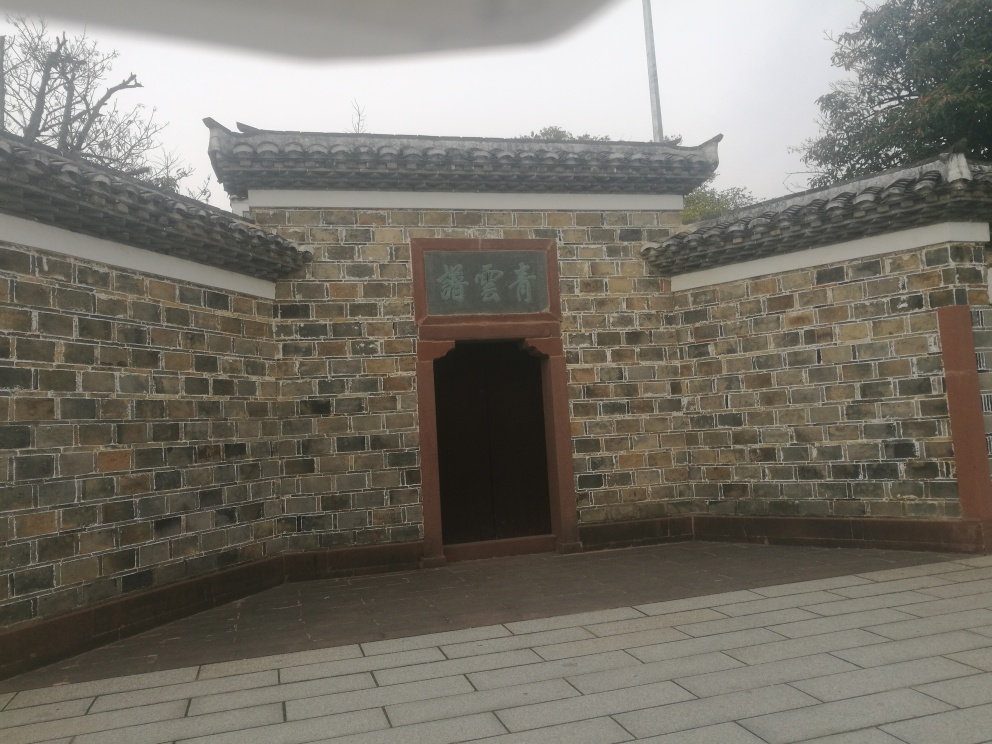What does the sign on the building say? The sign on the building is inscribed with East Asian characters. Due to the low resolution of the image, the exact characters are not clearly legible. Typically, such signs might indicate the name of the place, its historical significance, or an auspicious phrase, often found in historic sites or culturally significant buildings. 